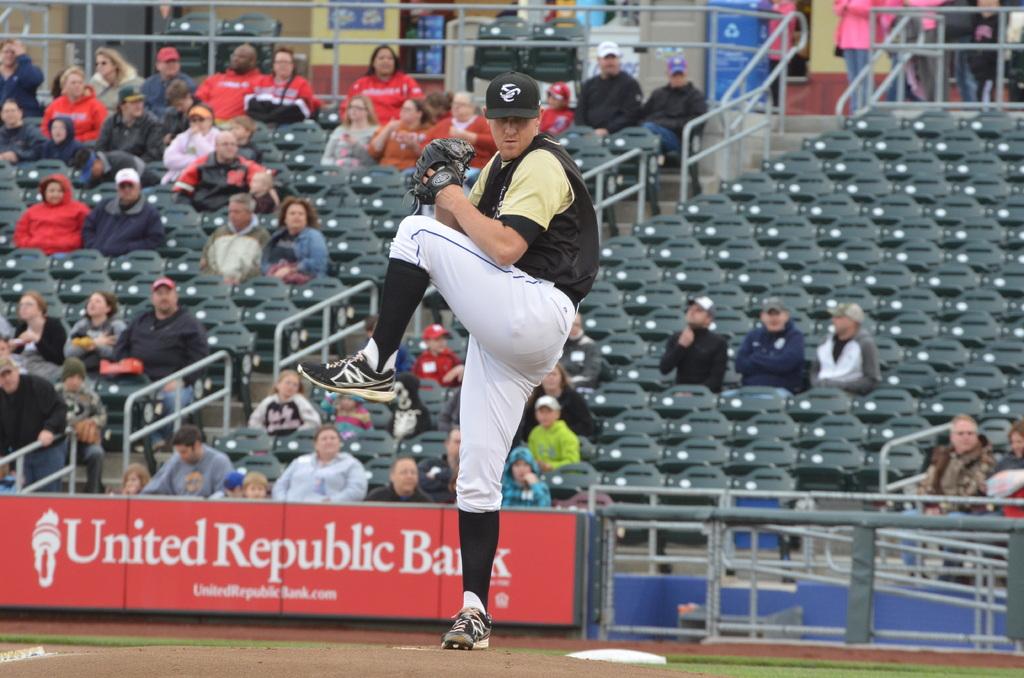What bank is a sponsor of this ballpark?
Provide a short and direct response. United republic bank. 